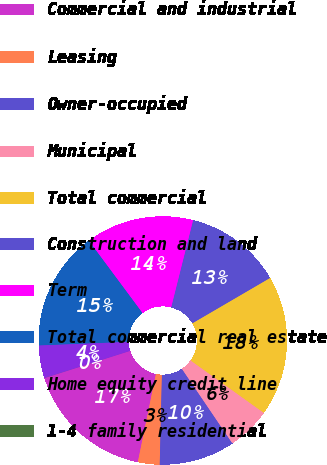<chart> <loc_0><loc_0><loc_500><loc_500><pie_chart><fcel>Commercial and industrial<fcel>Leasing<fcel>Owner-occupied<fcel>Municipal<fcel>Total commercial<fcel>Construction and land<fcel>Term<fcel>Total commercial real estate<fcel>Home equity credit line<fcel>1-4 family residential<nl><fcel>16.89%<fcel>2.83%<fcel>9.86%<fcel>5.64%<fcel>18.3%<fcel>12.67%<fcel>14.08%<fcel>15.49%<fcel>4.23%<fcel>0.01%<nl></chart> 